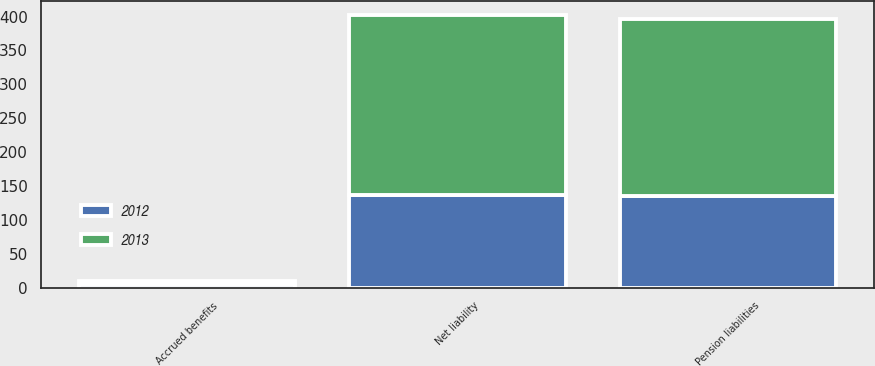Convert chart to OTSL. <chart><loc_0><loc_0><loc_500><loc_500><stacked_bar_chart><ecel><fcel>Accrued benefits<fcel>Pension liabilities<fcel>Net liability<nl><fcel>2012<fcel>4.8<fcel>135.8<fcel>136.9<nl><fcel>2013<fcel>4.6<fcel>260.7<fcel>265.3<nl></chart> 